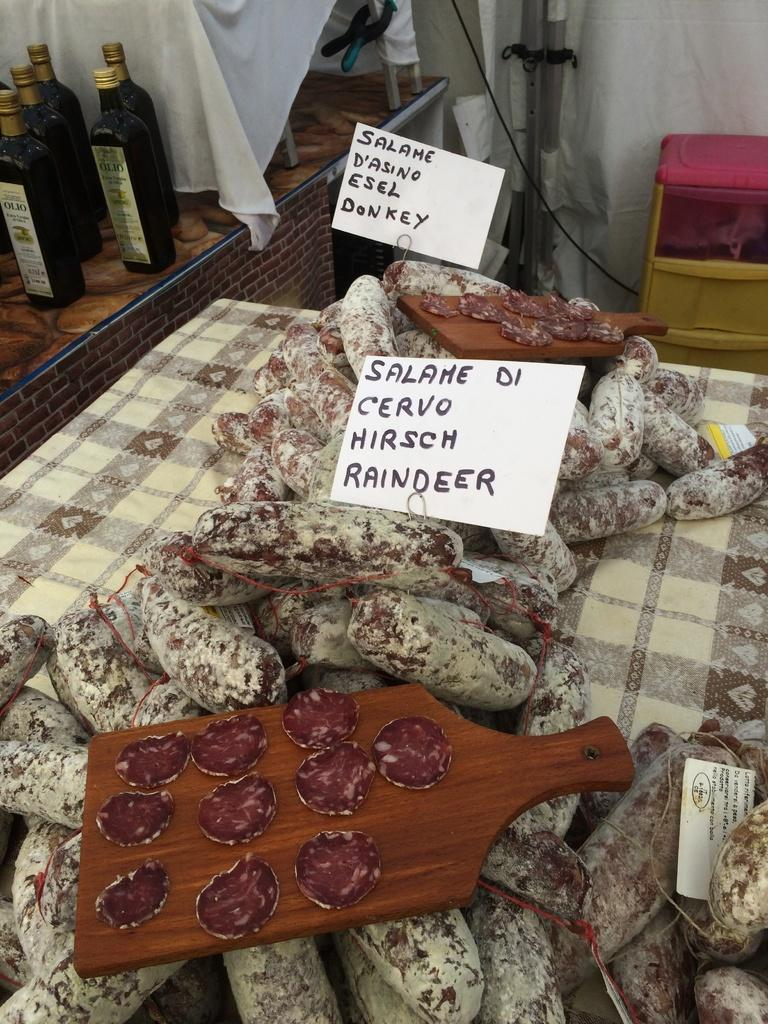<image>
Provide a brief description of the given image. A table displaying different meats on wooden boards and table with labels that say Raindeer and Donkey. 